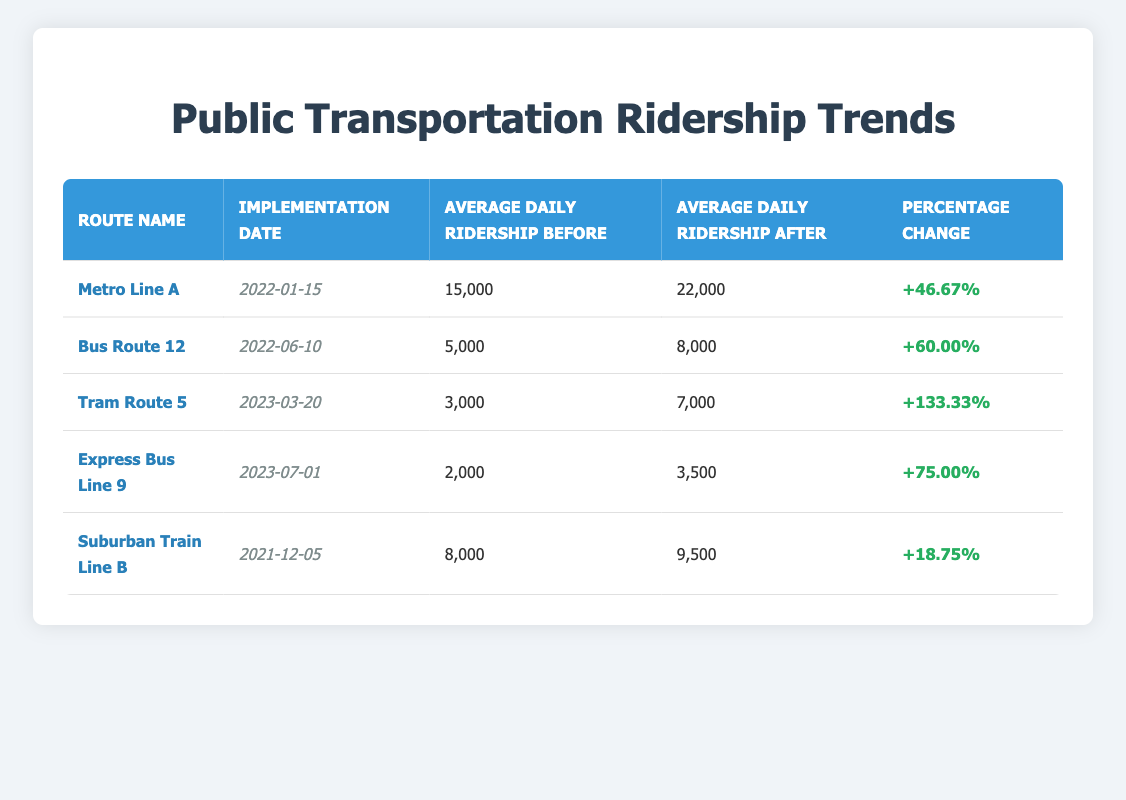What was the average daily ridership for Metro Line A before the new route was implemented? According to the table, the average daily ridership for Metro Line A before the implementation was 15,000.
Answer: 15,000 What percentage change in ridership occurred after the implementation of Bus Route 12? The table indicates that Bus Route 12 experienced a percentage change of 60.00% after its implementation.
Answer: 60.00% Which route had the highest percentage change in ridership after implementation? By comparing the percentage changes listed in the table, Tram Route 5 had the highest percentage change at 133.33%.
Answer: Tram Route 5 Is the average daily ridership after the implementation of Express Bus Line 9 higher than 4,000? The table shows that the average daily ridership after the implementation of Express Bus Line 9 is 3,500, which is less than 4,000.
Answer: No What is the total average daily ridership before the implementation for all routes? To find the total average daily ridership before implementation, add the figures: 15,000 + 5,000 + 3,000 + 2,000 + 8,000 = 33,000.
Answer: 33,000 Which route saw a decrease in absolute ridership after the new route implementation? The table does not indicate any routes with a decrease in ridership; all listed routes experienced an increase after implementation.
Answer: No What was the average increase in ridership across all routes after implementation? To find the average increase, first calculate each route's increase: (22,000 - 15,000) + (8,000 - 5,000) + (7,000 - 3,000) + (3,500 - 2,000) + (9,500 - 8,000) = 7,000 + 3,000 + 4,000 + 1,500 + 1,500 = 17,000. There are 5 routes, so the average increase is 17,000 / 5 = 3,400.
Answer: 3,400 Which route had an average daily ridership of 8,000 before the implementation? The table shows that Bus Route 12 had an average daily ridership of 5,000, while Suburban Train Line B had an average daily ridership of 8,000 before implementation.
Answer: Suburban Train Line B Was the implementation date for Metro Line A earlier than that of Tram Route 5? The implementation date for Metro Line A is January 15, 2022, while Tram Route 5 was implemented on March 20, 2023. Since January is before March, this statement is true.
Answer: Yes 